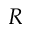<formula> <loc_0><loc_0><loc_500><loc_500>R</formula> 